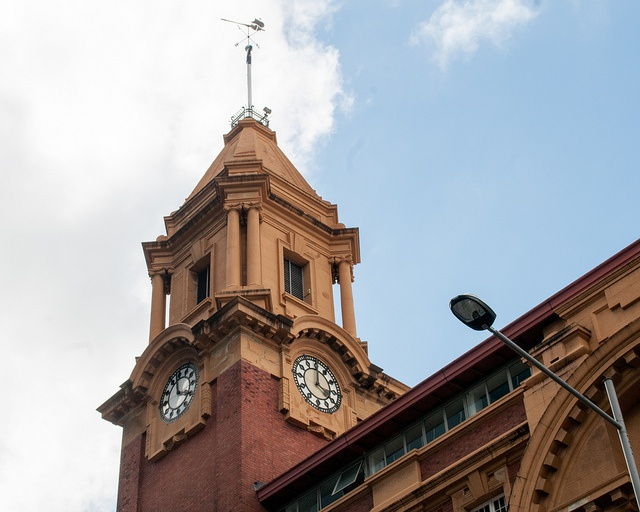Describe the objects in this image and their specific colors. I can see clock in white, lightgray, black, gray, and tan tones and clock in white, gray, black, darkgray, and lightgray tones in this image. 